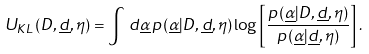<formula> <loc_0><loc_0><loc_500><loc_500>U _ { K L } \left ( D , \underline { d } , \eta \right ) = \int \, d \underline { \alpha } \, p \left ( \underline { \alpha } | D , \underline { d } , \eta \right ) \log \left [ \frac { p \left ( \underline { \alpha } | D , \underline { d } , \eta \right ) } { p \left ( \underline { \alpha } | \underline { d } , \eta \right ) } \right ] .</formula> 